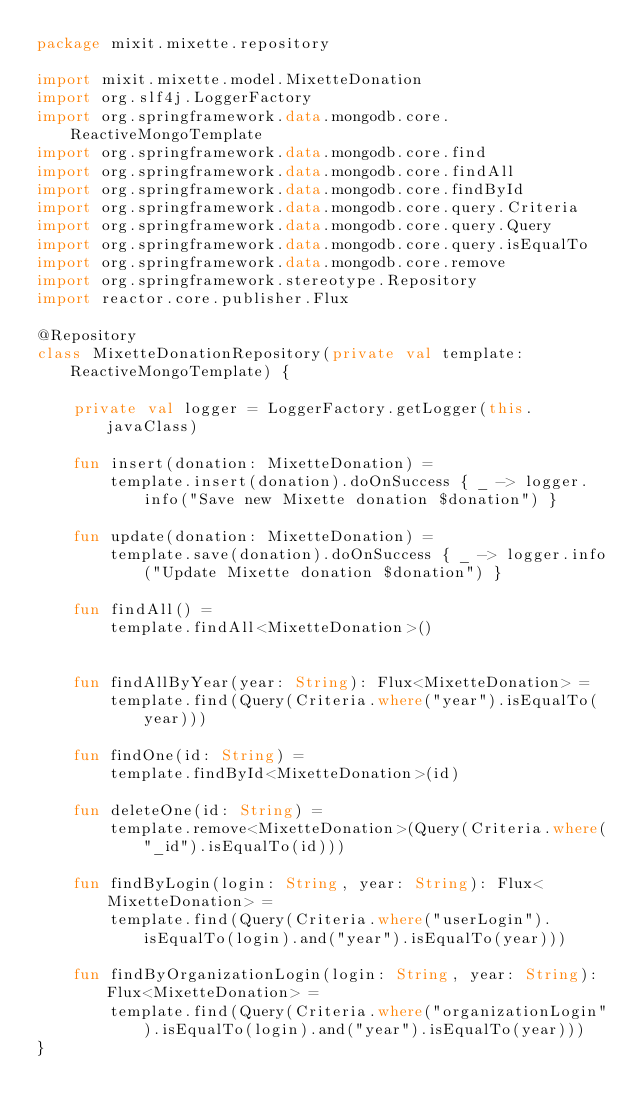<code> <loc_0><loc_0><loc_500><loc_500><_Kotlin_>package mixit.mixette.repository

import mixit.mixette.model.MixetteDonation
import org.slf4j.LoggerFactory
import org.springframework.data.mongodb.core.ReactiveMongoTemplate
import org.springframework.data.mongodb.core.find
import org.springframework.data.mongodb.core.findAll
import org.springframework.data.mongodb.core.findById
import org.springframework.data.mongodb.core.query.Criteria
import org.springframework.data.mongodb.core.query.Query
import org.springframework.data.mongodb.core.query.isEqualTo
import org.springframework.data.mongodb.core.remove
import org.springframework.stereotype.Repository
import reactor.core.publisher.Flux

@Repository
class MixetteDonationRepository(private val template: ReactiveMongoTemplate) {

    private val logger = LoggerFactory.getLogger(this.javaClass)

    fun insert(donation: MixetteDonation) =
        template.insert(donation).doOnSuccess { _ -> logger.info("Save new Mixette donation $donation") }

    fun update(donation: MixetteDonation) =
        template.save(donation).doOnSuccess { _ -> logger.info("Update Mixette donation $donation") }

    fun findAll() =
        template.findAll<MixetteDonation>()


    fun findAllByYear(year: String): Flux<MixetteDonation> =
        template.find(Query(Criteria.where("year").isEqualTo(year)))

    fun findOne(id: String) =
        template.findById<MixetteDonation>(id)

    fun deleteOne(id: String) =
        template.remove<MixetteDonation>(Query(Criteria.where("_id").isEqualTo(id)))

    fun findByLogin(login: String, year: String): Flux<MixetteDonation> =
        template.find(Query(Criteria.where("userLogin").isEqualTo(login).and("year").isEqualTo(year)))

    fun findByOrganizationLogin(login: String, year: String): Flux<MixetteDonation> =
        template.find(Query(Criteria.where("organizationLogin").isEqualTo(login).and("year").isEqualTo(year)))
}
</code> 